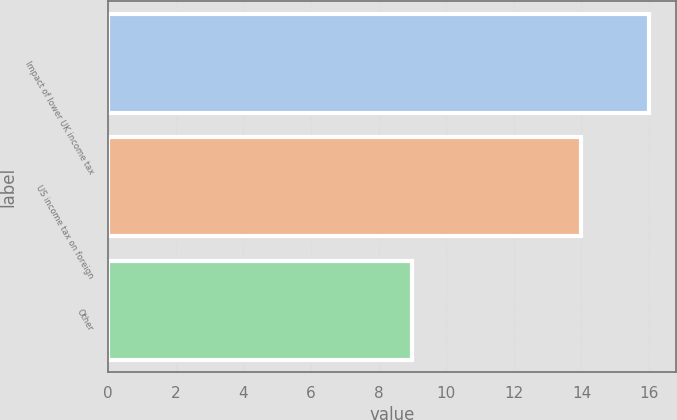Convert chart to OTSL. <chart><loc_0><loc_0><loc_500><loc_500><bar_chart><fcel>Impact of lower UK income tax<fcel>US income tax on foreign<fcel>Other<nl><fcel>16<fcel>14<fcel>9<nl></chart> 